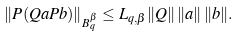<formula> <loc_0><loc_0><loc_500><loc_500>\| P ( Q a P b ) \| _ { B _ { q } ^ { \beta } } \leq L _ { q , \beta } \| Q \| \, \| a \| \, \| b \| .</formula> 